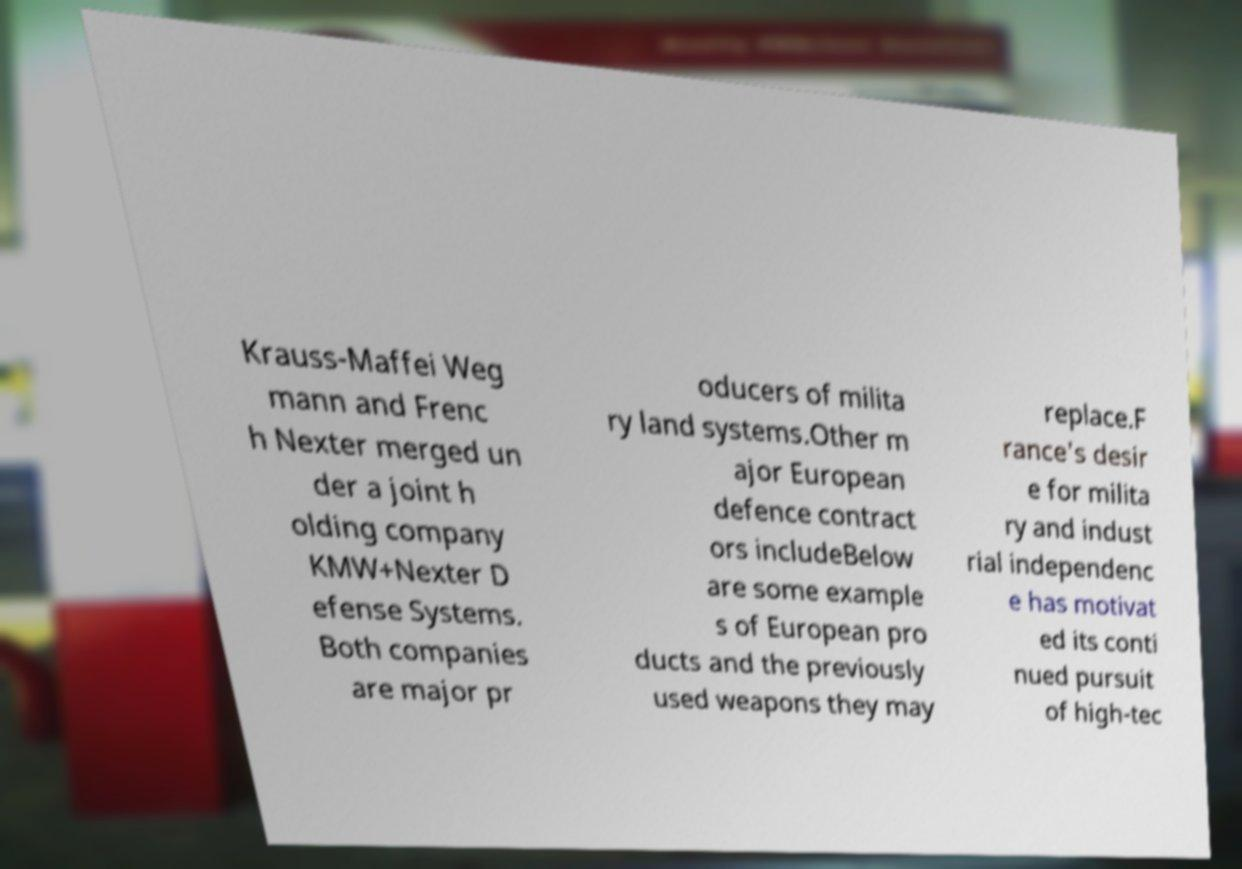Can you accurately transcribe the text from the provided image for me? Krauss-Maffei Weg mann and Frenc h Nexter merged un der a joint h olding company KMW+Nexter D efense Systems. Both companies are major pr oducers of milita ry land systems.Other m ajor European defence contract ors includeBelow are some example s of European pro ducts and the previously used weapons they may replace.F rance's desir e for milita ry and indust rial independenc e has motivat ed its conti nued pursuit of high-tec 